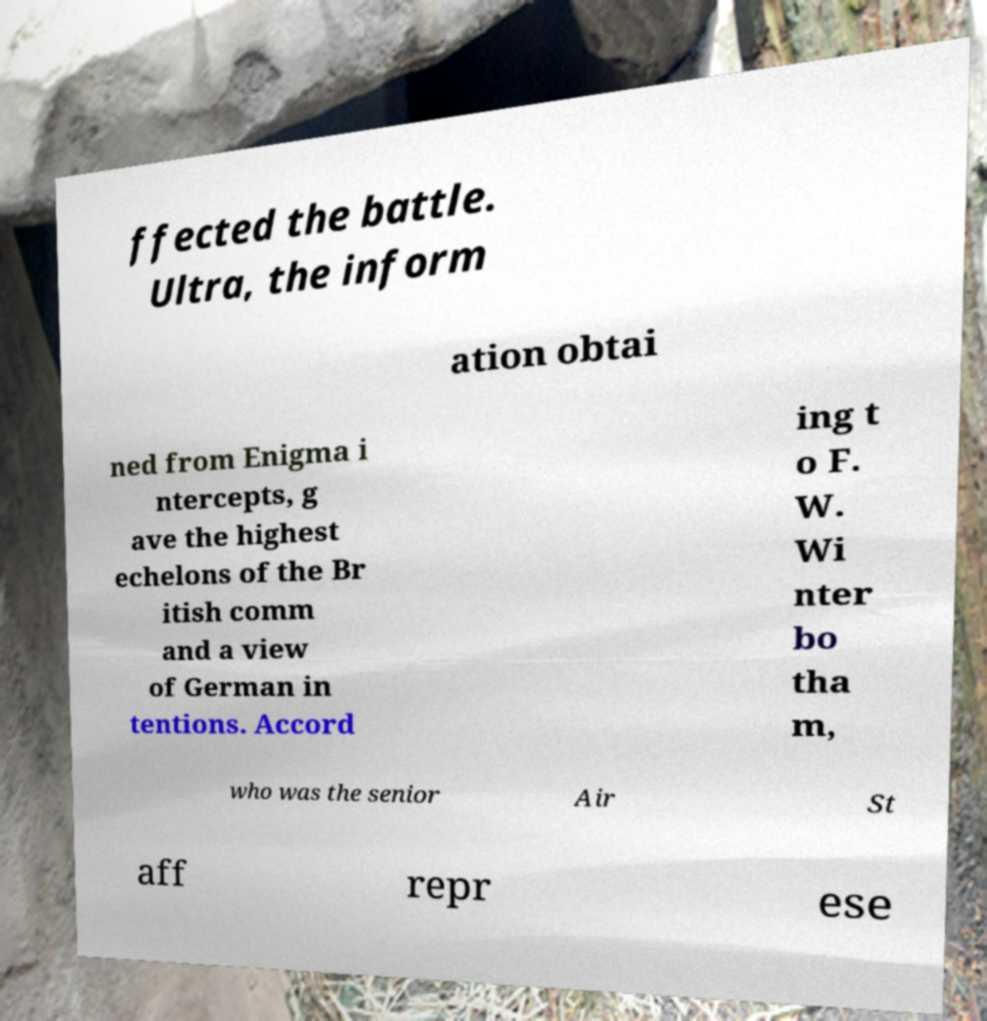Could you extract and type out the text from this image? ffected the battle. Ultra, the inform ation obtai ned from Enigma i ntercepts, g ave the highest echelons of the Br itish comm and a view of German in tentions. Accord ing t o F. W. Wi nter bo tha m, who was the senior Air St aff repr ese 